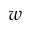Convert formula to latex. <formula><loc_0><loc_0><loc_500><loc_500>w</formula> 